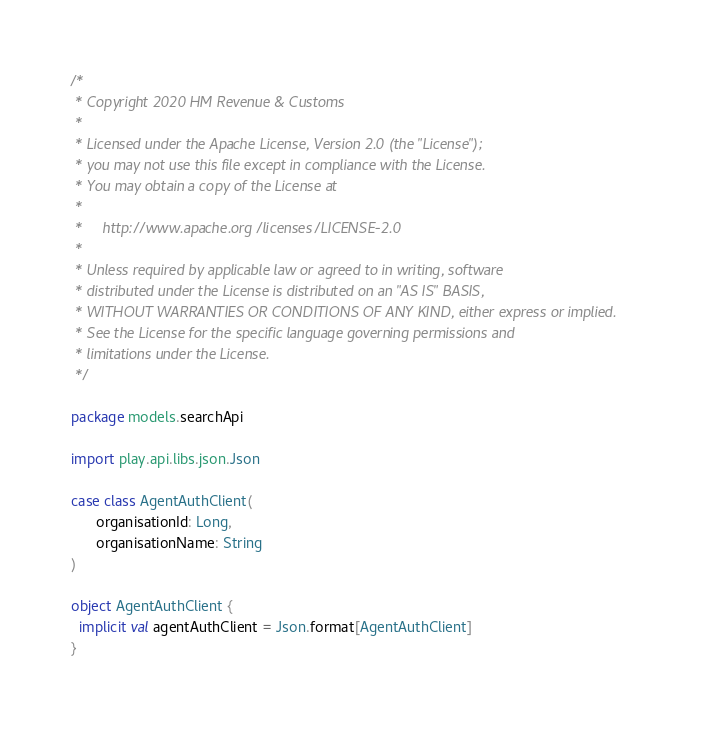<code> <loc_0><loc_0><loc_500><loc_500><_Scala_>/*
 * Copyright 2020 HM Revenue & Customs
 *
 * Licensed under the Apache License, Version 2.0 (the "License");
 * you may not use this file except in compliance with the License.
 * You may obtain a copy of the License at
 *
 *     http://www.apache.org/licenses/LICENSE-2.0
 *
 * Unless required by applicable law or agreed to in writing, software
 * distributed under the License is distributed on an "AS IS" BASIS,
 * WITHOUT WARRANTIES OR CONDITIONS OF ANY KIND, either express or implied.
 * See the License for the specific language governing permissions and
 * limitations under the License.
 */

package models.searchApi

import play.api.libs.json.Json

case class AgentAuthClient(
      organisationId: Long,
      organisationName: String
)

object AgentAuthClient {
  implicit val agentAuthClient = Json.format[AgentAuthClient]
}
</code> 